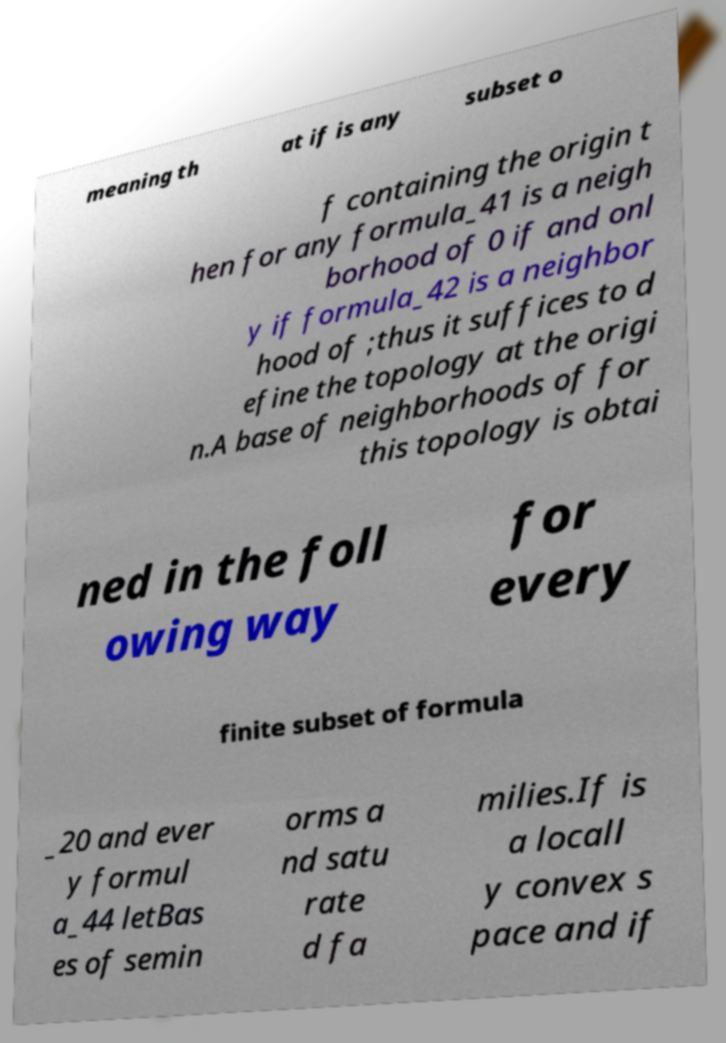For documentation purposes, I need the text within this image transcribed. Could you provide that? meaning th at if is any subset o f containing the origin t hen for any formula_41 is a neigh borhood of 0 if and onl y if formula_42 is a neighbor hood of ;thus it suffices to d efine the topology at the origi n.A base of neighborhoods of for this topology is obtai ned in the foll owing way for every finite subset of formula _20 and ever y formul a_44 letBas es of semin orms a nd satu rate d fa milies.If is a locall y convex s pace and if 